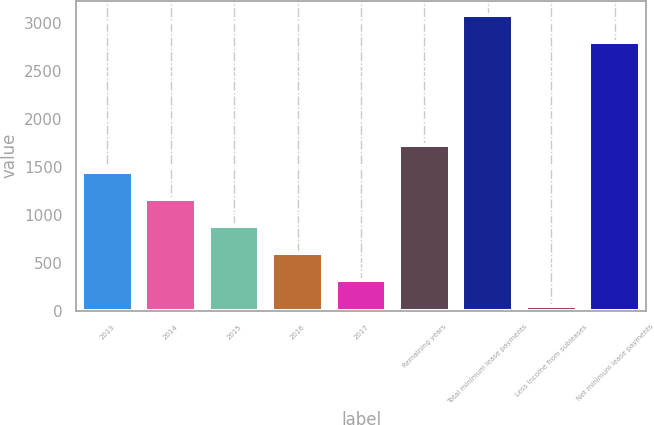Convert chart. <chart><loc_0><loc_0><loc_500><loc_500><bar_chart><fcel>2013<fcel>2014<fcel>2015<fcel>2016<fcel>2017<fcel>Remaining years<fcel>Total minimum lease payments<fcel>Less Income from subleases<fcel>Net minimum lease payments<nl><fcel>1443<fcel>1163<fcel>883<fcel>603<fcel>323<fcel>1723<fcel>3080<fcel>43<fcel>2800<nl></chart> 